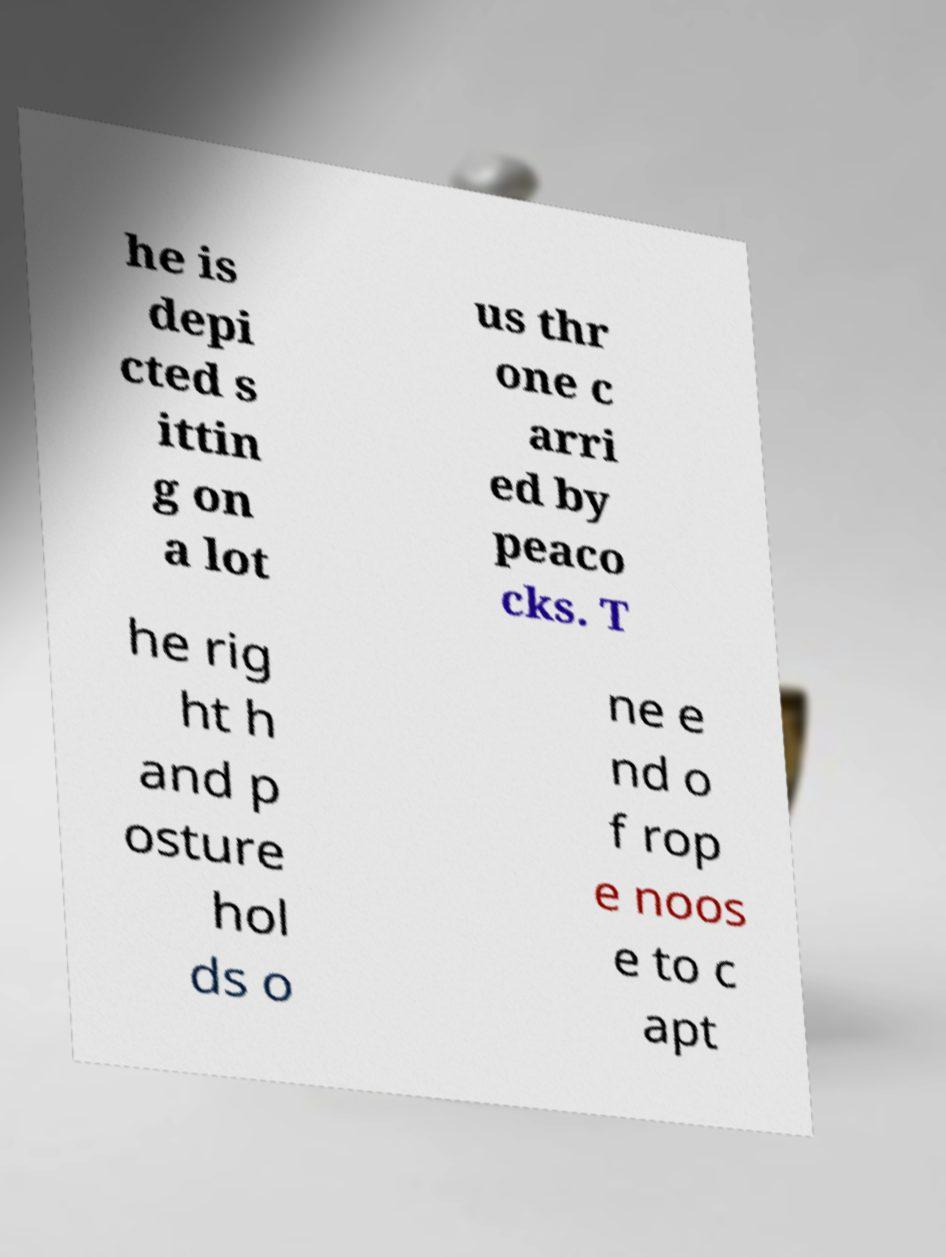Can you accurately transcribe the text from the provided image for me? he is depi cted s ittin g on a lot us thr one c arri ed by peaco cks. T he rig ht h and p osture hol ds o ne e nd o f rop e noos e to c apt 